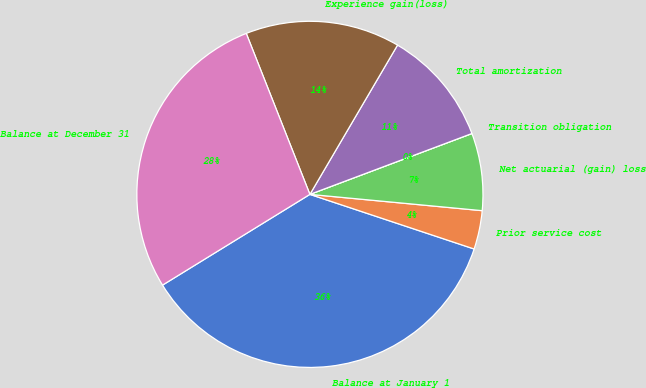Convert chart. <chart><loc_0><loc_0><loc_500><loc_500><pie_chart><fcel>Balance at January 1<fcel>Prior service cost<fcel>Net actuarial (gain) loss<fcel>Transition obligation<fcel>Total amortization<fcel>Experience gain(loss)<fcel>Balance at December 31<nl><fcel>36.1%<fcel>3.61%<fcel>7.22%<fcel>0.0%<fcel>10.83%<fcel>14.44%<fcel>27.79%<nl></chart> 